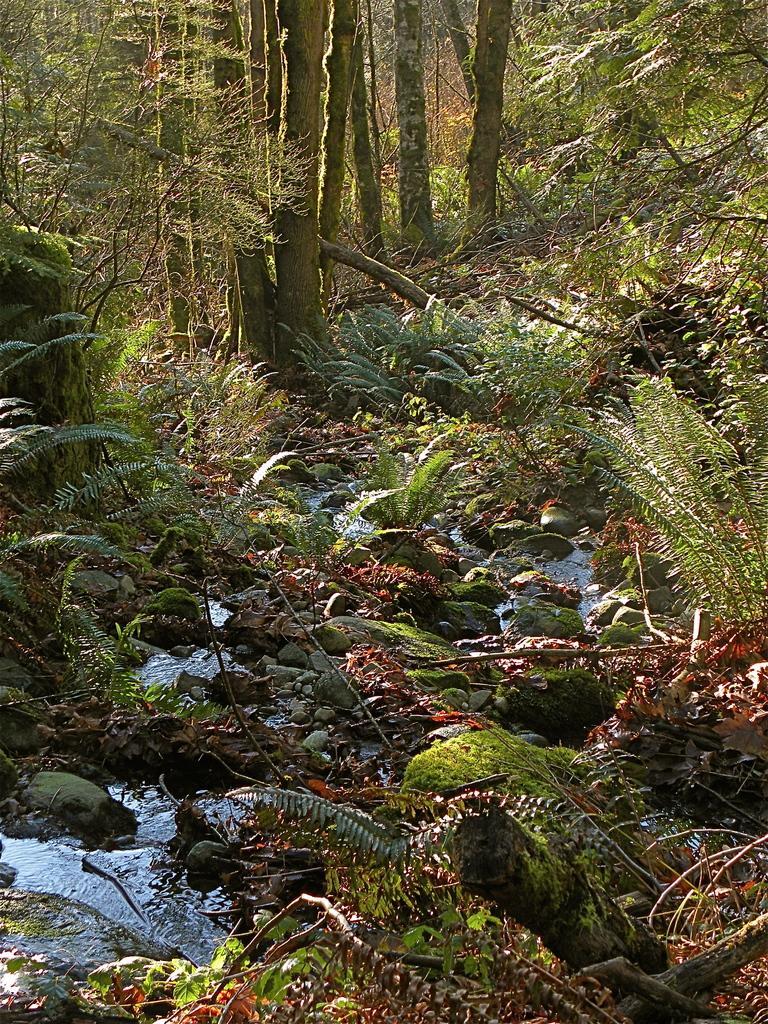Describe this image in one or two sentences. In this picture I can see water. I can see the stones. I can see planets on the left and right side. I can see trees in the background. 